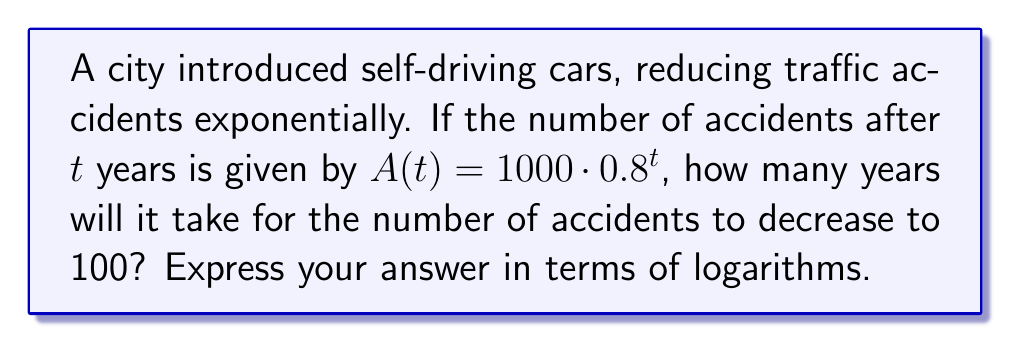Help me with this question. To solve this problem, we need to use logarithms to isolate the variable $t$. Let's approach this step-by-step:

1) We start with the equation: $A(t) = 1000 \cdot 0.8^t$

2) We want to find $t$ when $A(t) = 100$. So, let's set up the equation:
   $100 = 1000 \cdot 0.8^t$

3) Divide both sides by 1000:
   $\frac{100}{1000} = 0.8^t$

4) Simplify:
   $0.1 = 0.8^t$

5) Now, we can apply logarithms to both sides. We'll use log base 0.8 for simplicity:
   $\log_{0.8}(0.1) = \log_{0.8}(0.8^t)$

6) The right side simplifies due to the logarithm property $\log_a(a^x) = x$:
   $\log_{0.8}(0.1) = t$

7) To express this in terms of natural logarithms (ln), we can use the change of base formula:
   $t = \frac{\ln(0.1)}{\ln(0.8)}$

This is our final answer, expressed in terms of natural logarithms.
Answer: $\frac{\ln(0.1)}{\ln(0.8)}$ 